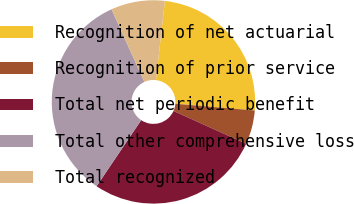<chart> <loc_0><loc_0><loc_500><loc_500><pie_chart><fcel>Recognition of net actuarial<fcel>Recognition of prior service<fcel>Total net periodic benefit<fcel>Total other comprehensive loss<fcel>Total recognized<nl><fcel>24.55%<fcel>5.41%<fcel>27.7%<fcel>33.78%<fcel>8.56%<nl></chart> 